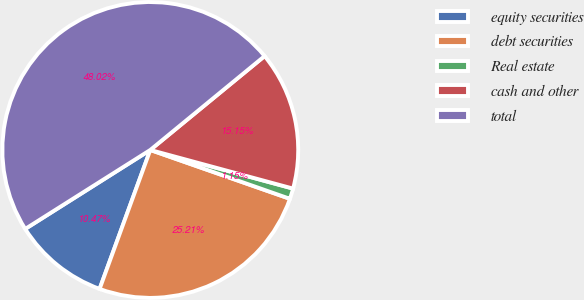<chart> <loc_0><loc_0><loc_500><loc_500><pie_chart><fcel>equity securities<fcel>debt securities<fcel>Real estate<fcel>cash and other<fcel>total<nl><fcel>10.47%<fcel>25.21%<fcel>1.15%<fcel>15.15%<fcel>48.02%<nl></chart> 